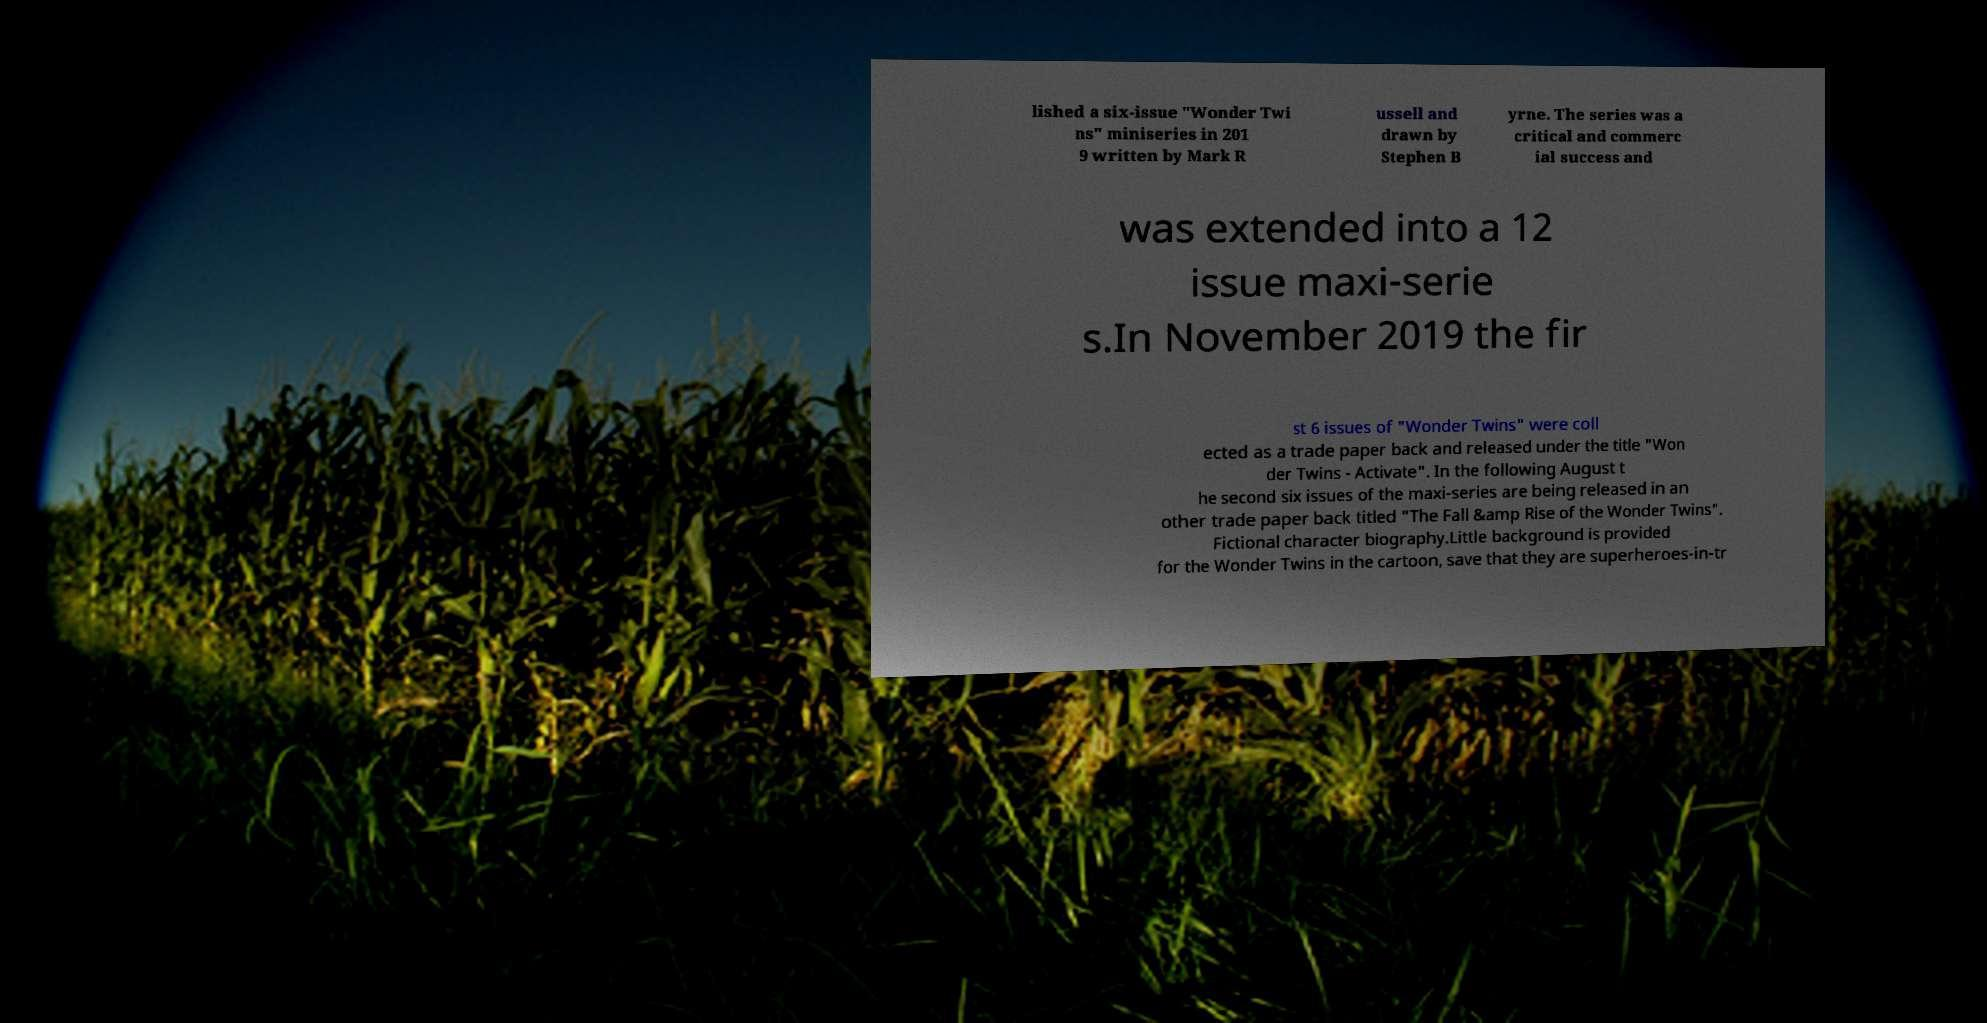Can you accurately transcribe the text from the provided image for me? lished a six-issue "Wonder Twi ns" miniseries in 201 9 written by Mark R ussell and drawn by Stephen B yrne. The series was a critical and commerc ial success and was extended into a 12 issue maxi-serie s.In November 2019 the fir st 6 issues of "Wonder Twins" were coll ected as a trade paper back and released under the title "Won der Twins - Activate". In the following August t he second six issues of the maxi-series are being released in an other trade paper back titled "The Fall &amp Rise of the Wonder Twins". Fictional character biography.Little background is provided for the Wonder Twins in the cartoon, save that they are superheroes-in-tr 